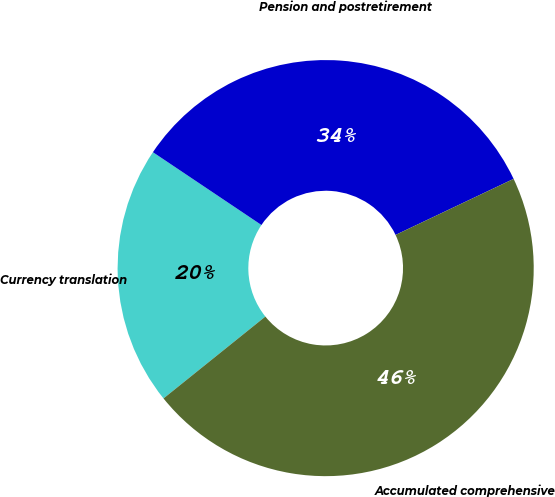<chart> <loc_0><loc_0><loc_500><loc_500><pie_chart><fcel>Currency translation<fcel>Pension and postretirement<fcel>Accumulated comprehensive<nl><fcel>20.18%<fcel>33.54%<fcel>46.28%<nl></chart> 